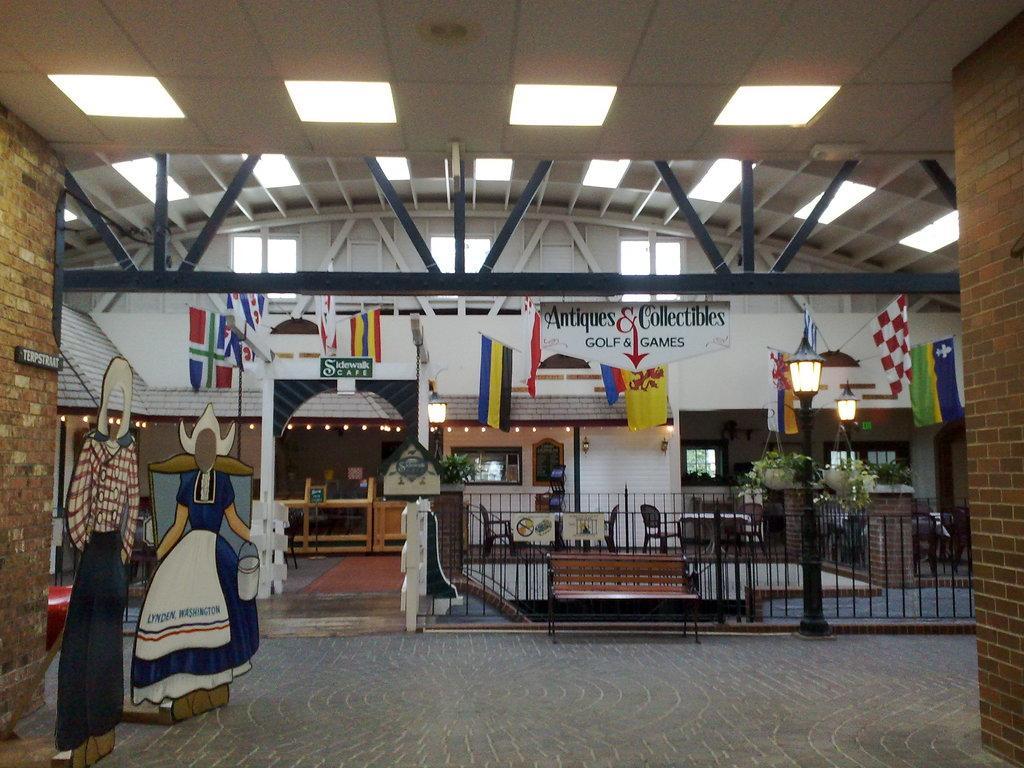In one or two sentences, can you explain what this image depicts? In this picture I can see a building and few flags and a board with some text and I can see a bench and a metal fence and few plants in the pots and I can see couple of paintings on the side and few lights to the ceiling. 